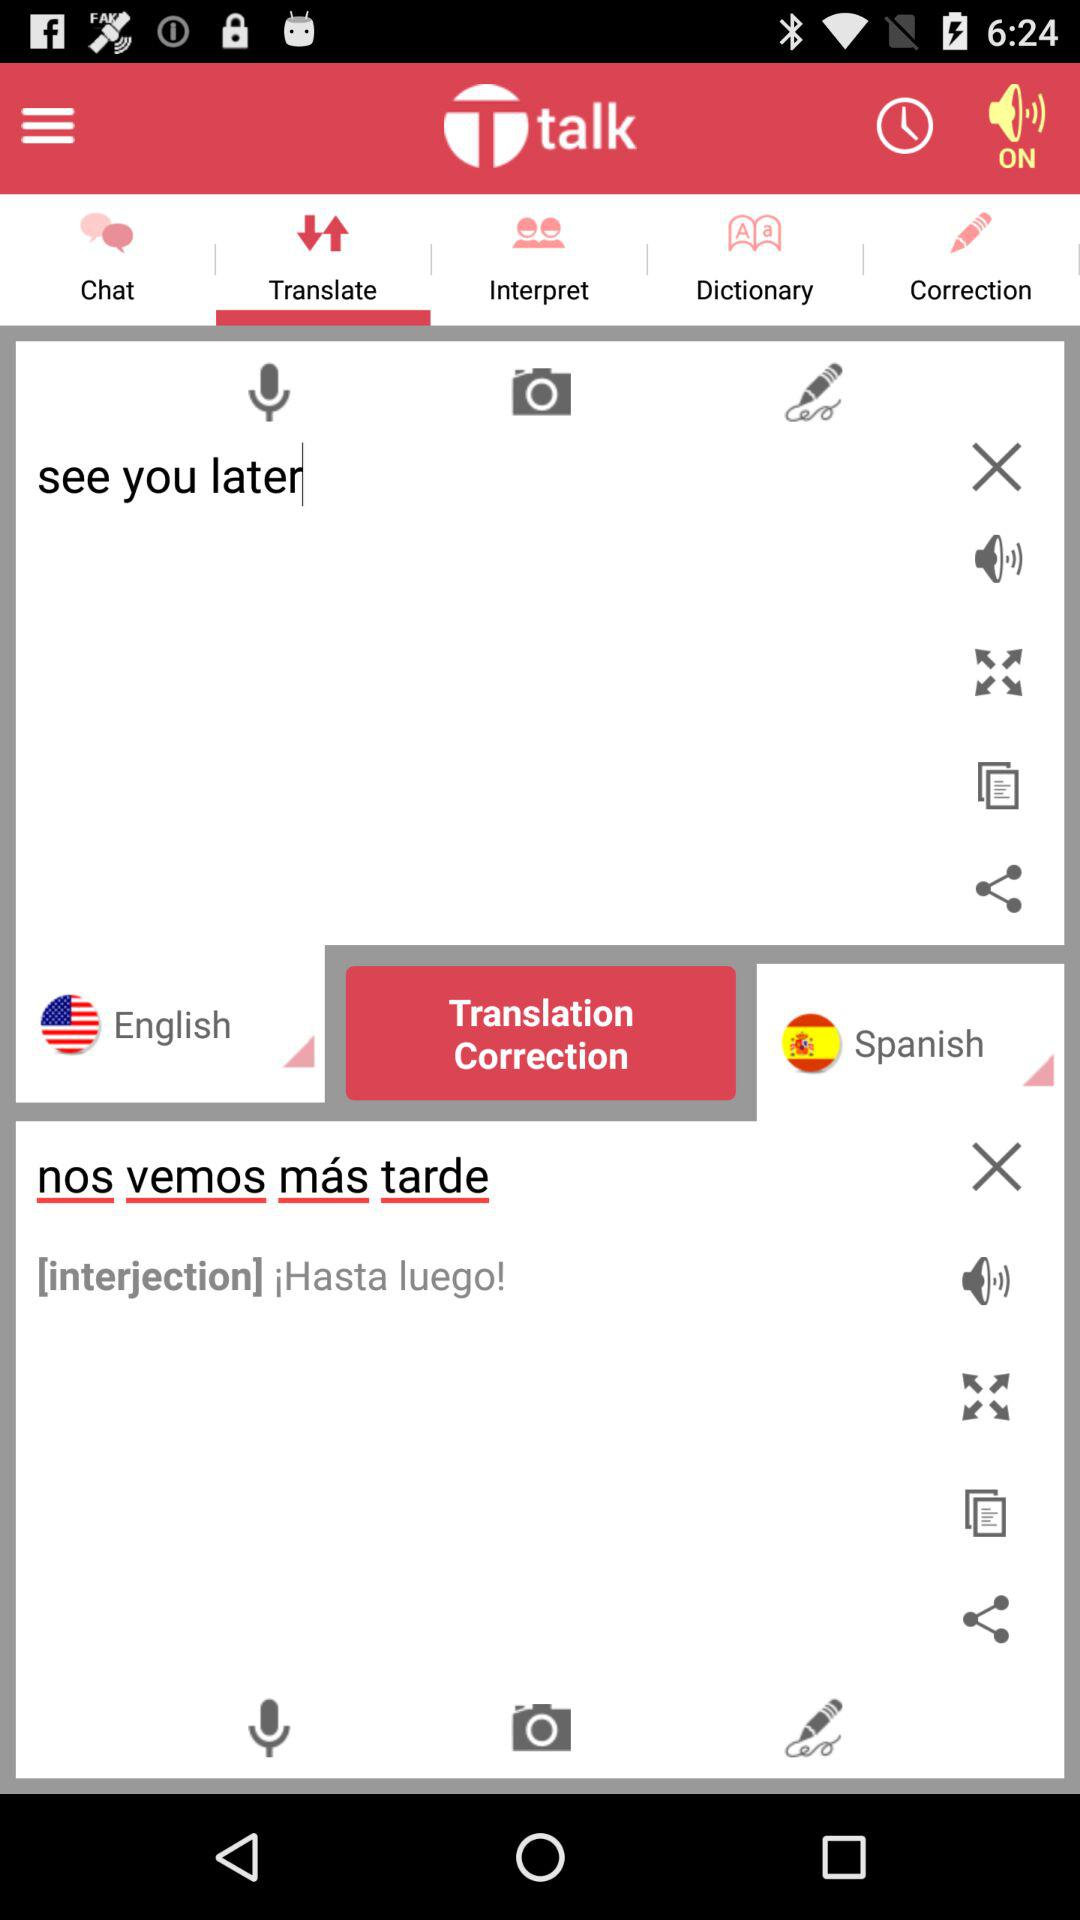How many languages are available for translation?
Answer the question using a single word or phrase. 2 